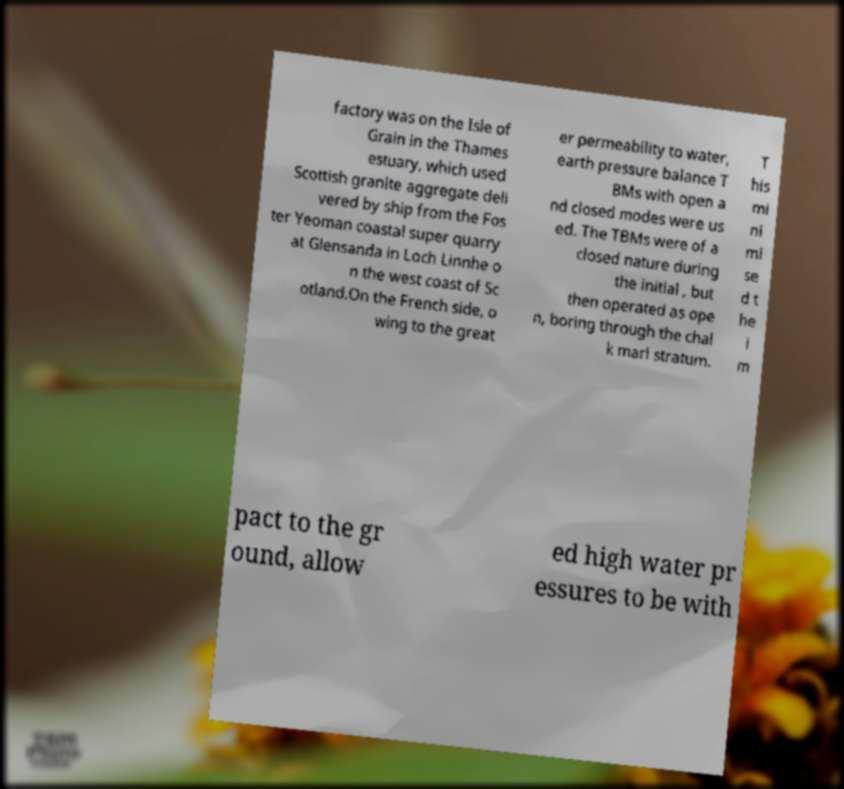Please identify and transcribe the text found in this image. factory was on the Isle of Grain in the Thames estuary, which used Scottish granite aggregate deli vered by ship from the Fos ter Yeoman coastal super quarry at Glensanda in Loch Linnhe o n the west coast of Sc otland.On the French side, o wing to the great er permeability to water, earth pressure balance T BMs with open a nd closed modes were us ed. The TBMs were of a closed nature during the initial , but then operated as ope n, boring through the chal k marl stratum. T his mi ni mi se d t he i m pact to the gr ound, allow ed high water pr essures to be with 